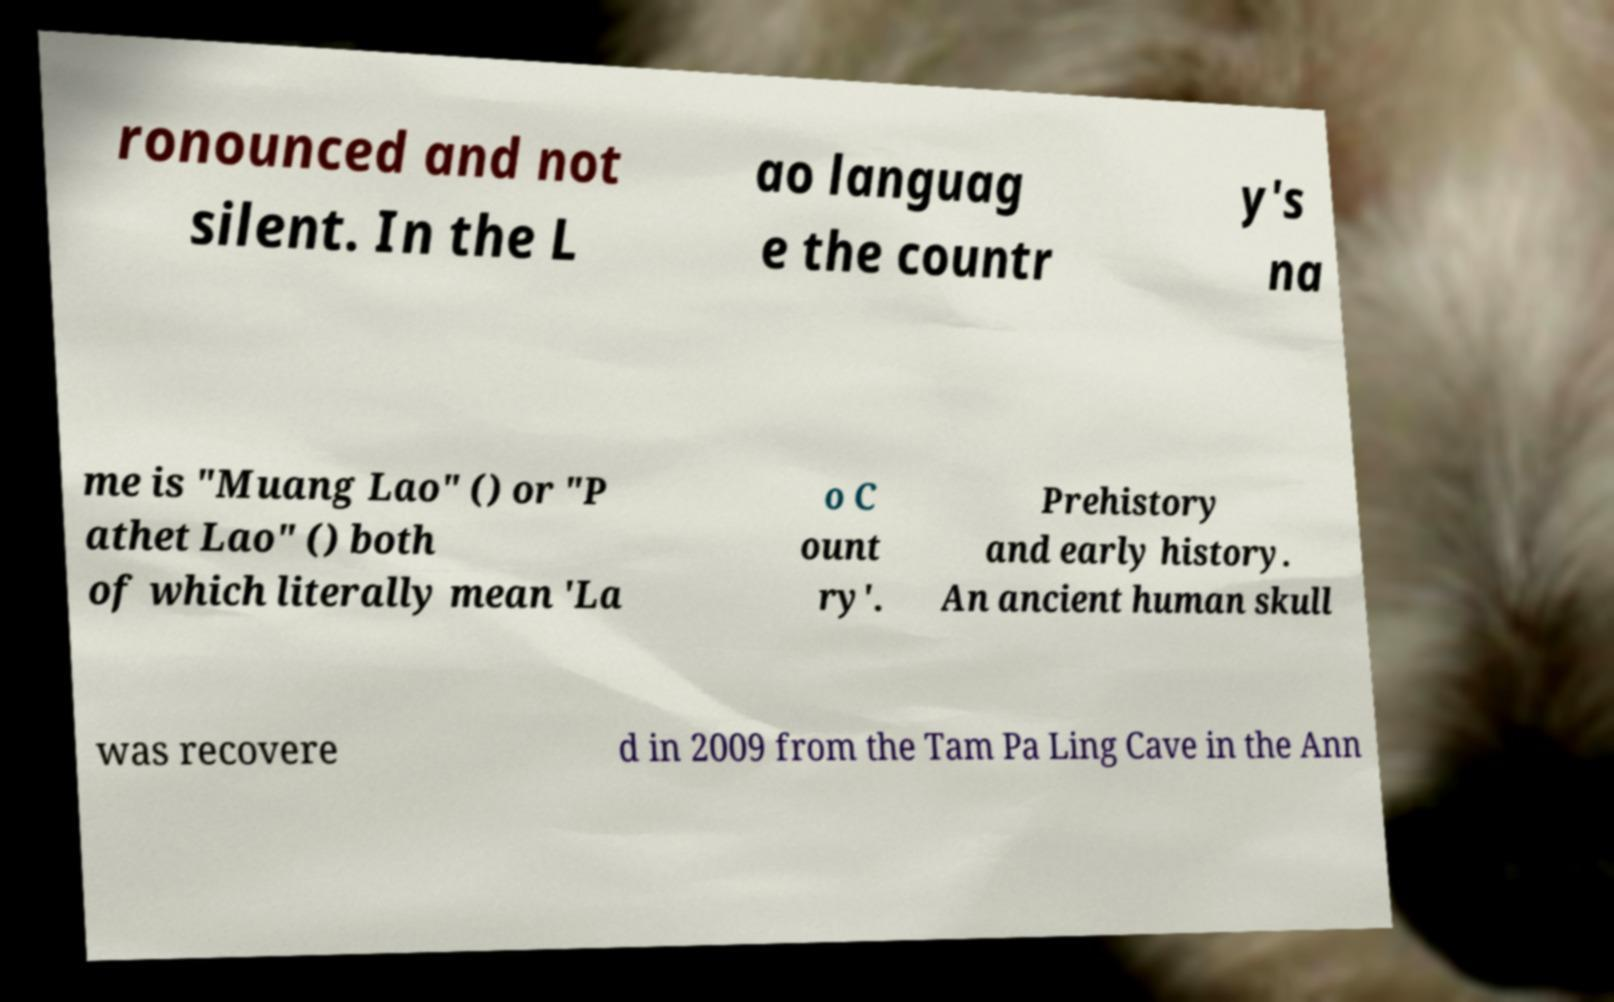Please identify and transcribe the text found in this image. ronounced and not silent. In the L ao languag e the countr y's na me is "Muang Lao" () or "P athet Lao" () both of which literally mean 'La o C ount ry'. Prehistory and early history. An ancient human skull was recovere d in 2009 from the Tam Pa Ling Cave in the Ann 